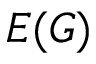<formula> <loc_0><loc_0><loc_500><loc_500>E ( G )</formula> 